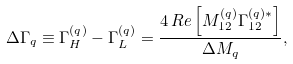<formula> <loc_0><loc_0><loc_500><loc_500>\Delta \Gamma _ { q } \equiv \Gamma _ { H } ^ { ( q ) } - \Gamma _ { L } ^ { ( q ) } = \frac { 4 \, R e \left [ M _ { 1 2 } ^ { ( q ) } \Gamma _ { 1 2 } ^ { ( q ) \ast } \right ] } { \Delta M _ { q } } ,</formula> 